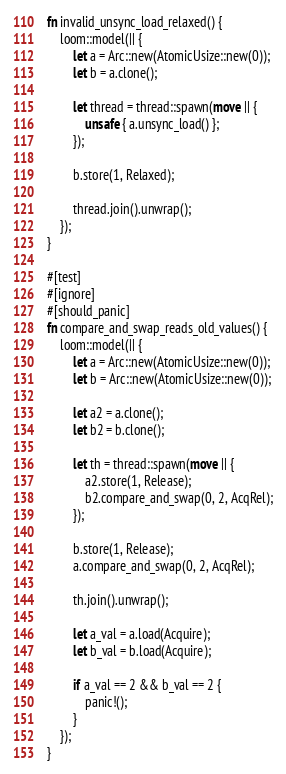Convert code to text. <code><loc_0><loc_0><loc_500><loc_500><_Rust_>fn invalid_unsync_load_relaxed() {
    loom::model(|| {
        let a = Arc::new(AtomicUsize::new(0));
        let b = a.clone();

        let thread = thread::spawn(move || {
            unsafe { a.unsync_load() };
        });

        b.store(1, Relaxed);

        thread.join().unwrap();
    });
}

#[test]
#[ignore]
#[should_panic]
fn compare_and_swap_reads_old_values() {
    loom::model(|| {
        let a = Arc::new(AtomicUsize::new(0));
        let b = Arc::new(AtomicUsize::new(0));

        let a2 = a.clone();
        let b2 = b.clone();

        let th = thread::spawn(move || {
            a2.store(1, Release);
            b2.compare_and_swap(0, 2, AcqRel);
        });

        b.store(1, Release);
        a.compare_and_swap(0, 2, AcqRel);

        th.join().unwrap();

        let a_val = a.load(Acquire);
        let b_val = b.load(Acquire);

        if a_val == 2 && b_val == 2 {
            panic!();
        }
    });
}
</code> 